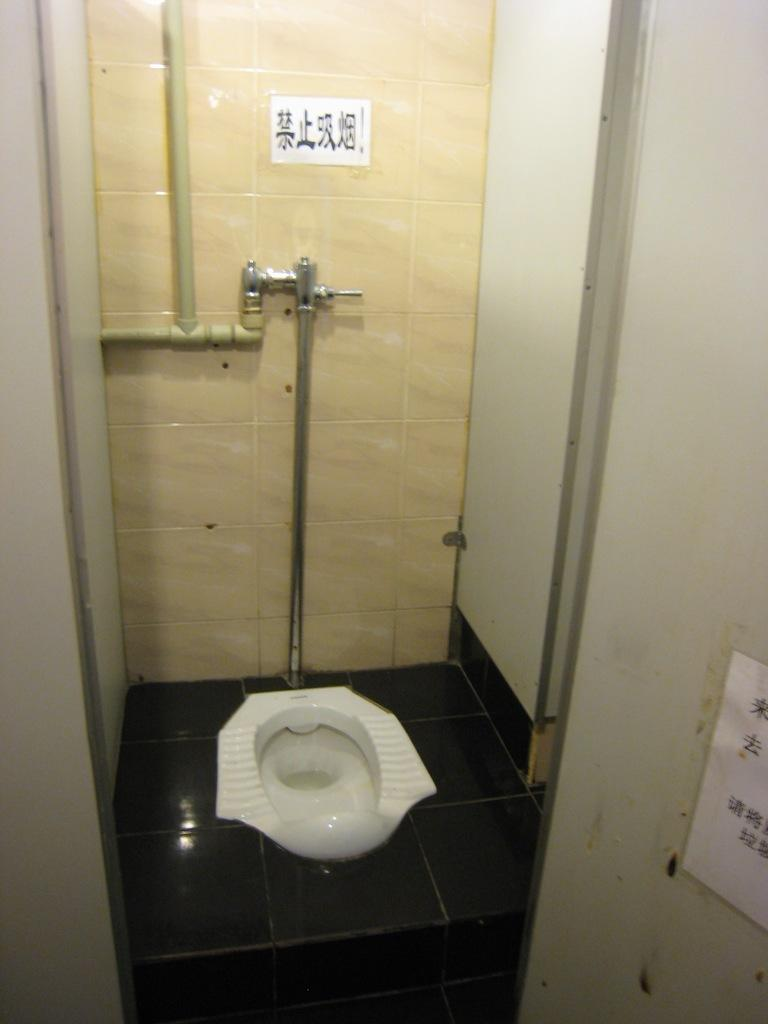What is the main object in the middle of the image? There is a commode in the middle of the image. What type of flooring can be seen in the background of the image? There are tiles visible in the background of the image. What else can be seen in the background of the image? There are pipes in the background of the image. Where is the paper located in the image? The paper is pasted at the right bottom of the image. What type of liquid is being consumed by the goose in the image? There is no goose present in the image, so it is not possible to determine what, if any, liquid is being consumed. 